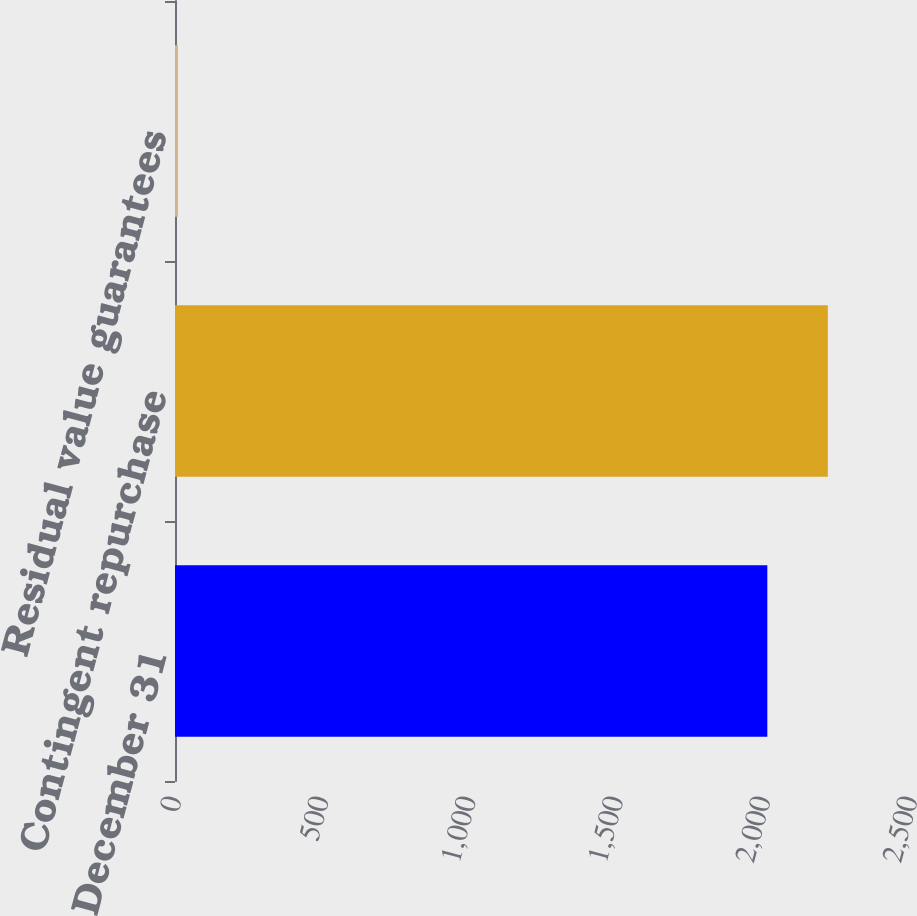Convert chart. <chart><loc_0><loc_0><loc_500><loc_500><bar_chart><fcel>December 31<fcel>Contingent repurchase<fcel>Residual value guarantees<nl><fcel>2012<fcel>2217.5<fcel>10<nl></chart> 